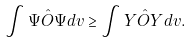<formula> <loc_0><loc_0><loc_500><loc_500>\int \Psi \hat { O } \Psi d v \geq \int Y \hat { O } Y d v .</formula> 